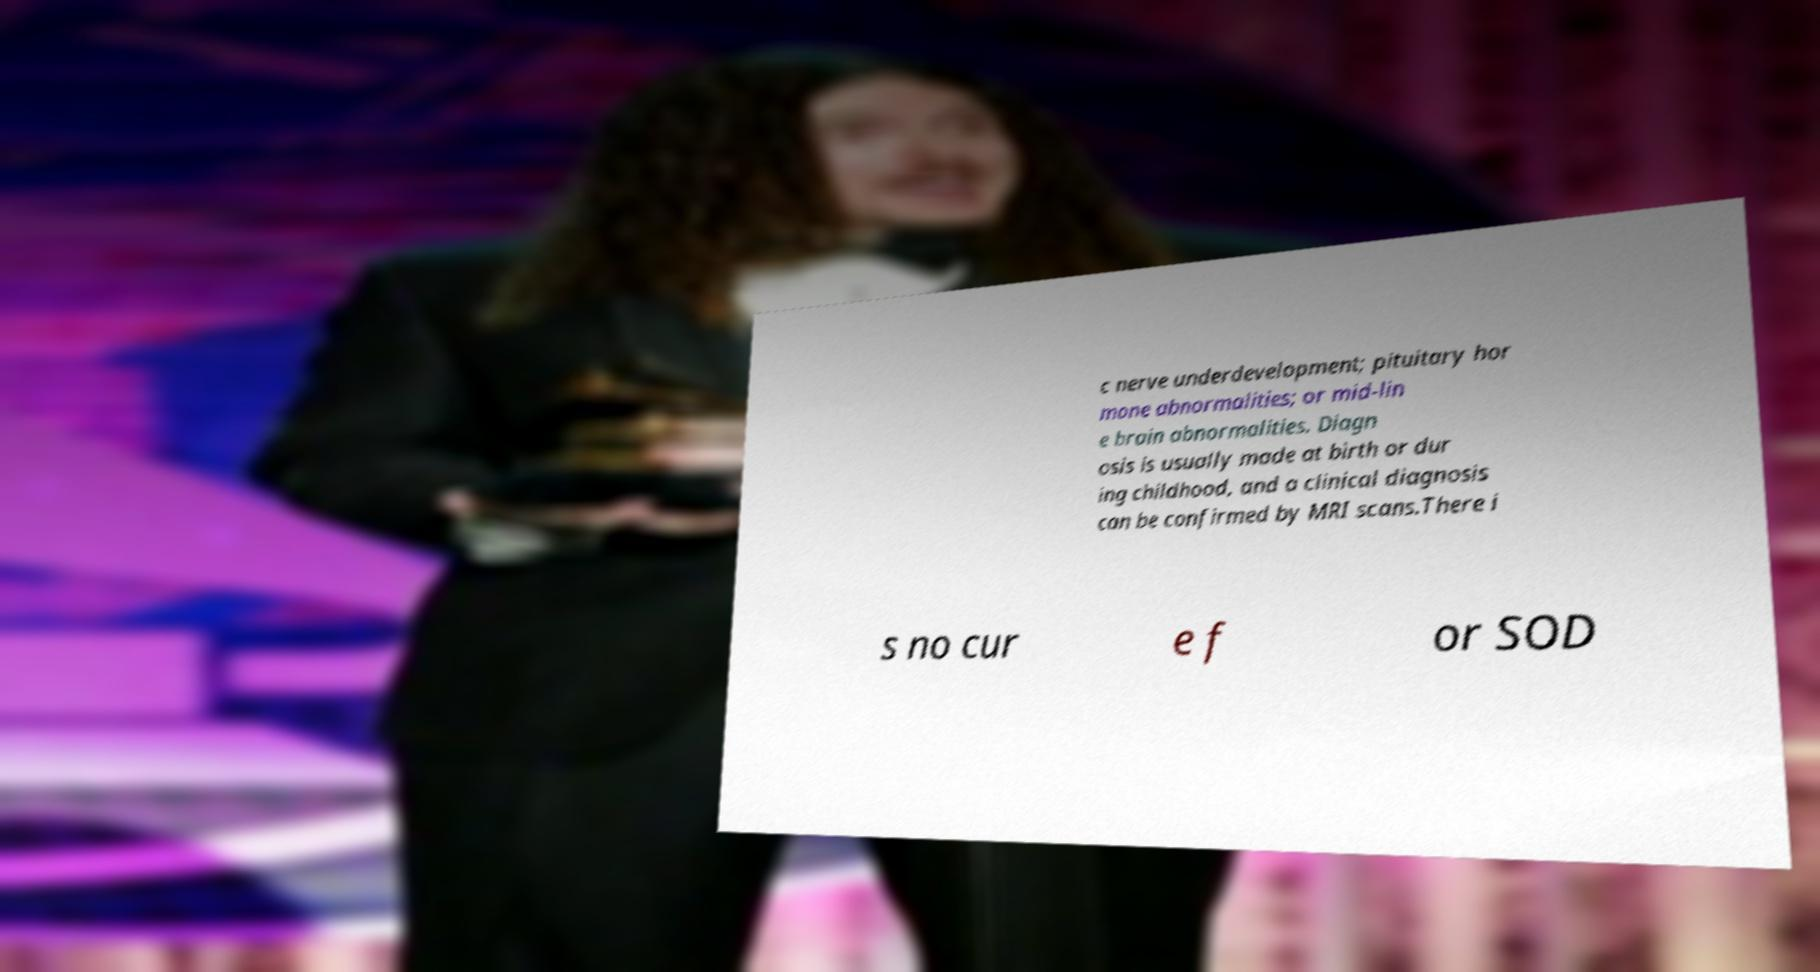Could you assist in decoding the text presented in this image and type it out clearly? c nerve underdevelopment; pituitary hor mone abnormalities; or mid-lin e brain abnormalities. Diagn osis is usually made at birth or dur ing childhood, and a clinical diagnosis can be confirmed by MRI scans.There i s no cur e f or SOD 